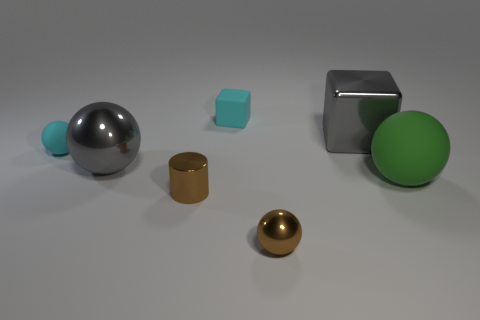There is a cylinder that is made of the same material as the brown sphere; what size is it?
Offer a terse response. Small. What number of blue things are either small matte objects or shiny cubes?
Your answer should be compact. 0. There is a ball on the right side of the gray block; what number of small spheres are behind it?
Your response must be concise. 1. Are there more gray metallic blocks in front of the large metallic block than brown cylinders that are left of the large gray sphere?
Provide a short and direct response. No. What material is the cyan cube?
Give a very brief answer. Rubber. Are there any cyan matte things that have the same size as the brown metallic cylinder?
Your answer should be compact. Yes. There is a brown sphere that is the same size as the cyan matte sphere; what is it made of?
Provide a succinct answer. Metal. What number of purple cylinders are there?
Give a very brief answer. 0. There is a shiny sphere that is behind the tiny brown metallic cylinder; what size is it?
Ensure brevity in your answer.  Large. Are there the same number of tiny objects in front of the matte block and large blocks?
Offer a terse response. No. 